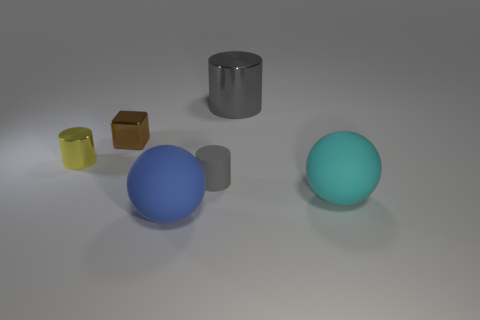Are there any cyan balls of the same size as the brown metal cube?
Offer a very short reply. No. What shape is the blue object that is the same size as the cyan rubber object?
Your response must be concise. Sphere. What number of other things are there of the same color as the block?
Provide a short and direct response. 0. What is the shape of the large object that is on the left side of the big cyan rubber object and in front of the big gray shiny cylinder?
Provide a short and direct response. Sphere. There is a metal thing on the right side of the large object on the left side of the matte cylinder; are there any metal objects that are left of it?
Your answer should be compact. Yes. How many other objects are the same material as the big cyan thing?
Your answer should be very brief. 2. What number of large cyan rubber things are there?
Your response must be concise. 1. What number of objects are small cyan cylinders or tiny metallic things to the right of the yellow metallic object?
Your answer should be compact. 1. Is there any other thing that is the same shape as the brown thing?
Keep it short and to the point. No. Is the size of the gray thing that is to the left of the gray metallic cylinder the same as the cyan ball?
Offer a very short reply. No. 